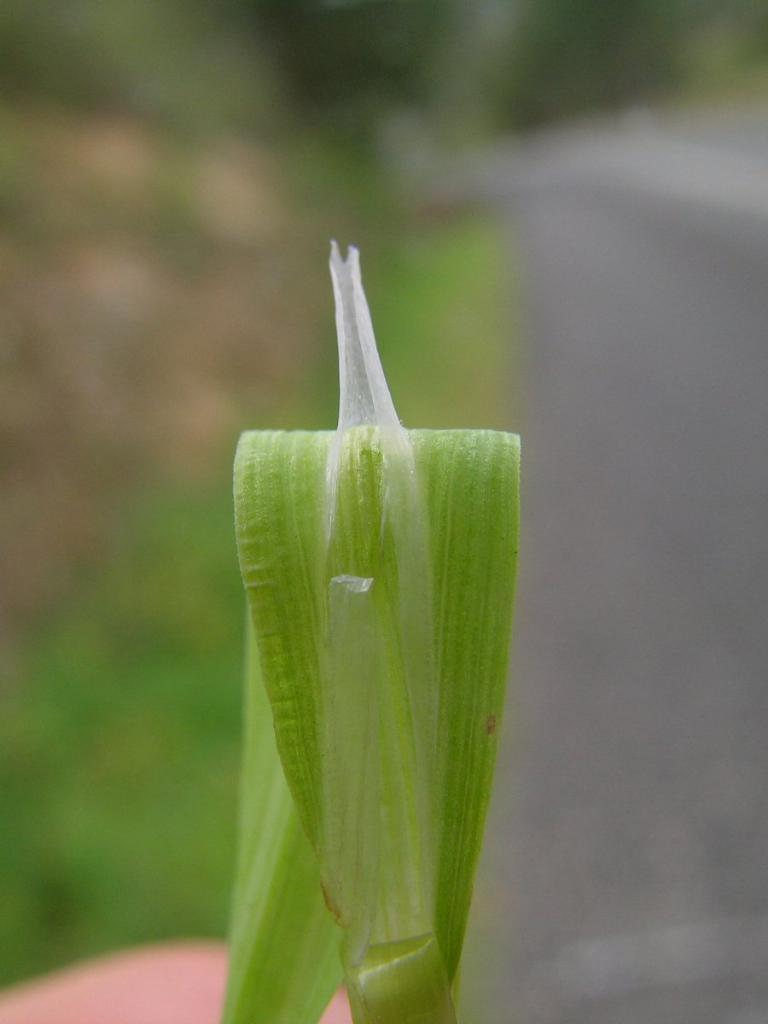What type of plant is represented in the image? The image contains a green leaf of a plant. Can you describe the appearance of the leaf? The outer layer of the leaf is pulled up. What type of ornament is hanging from the leaf in the image? There is no ornament present in the image; it only features a green leaf with a pulled-up outer layer. 